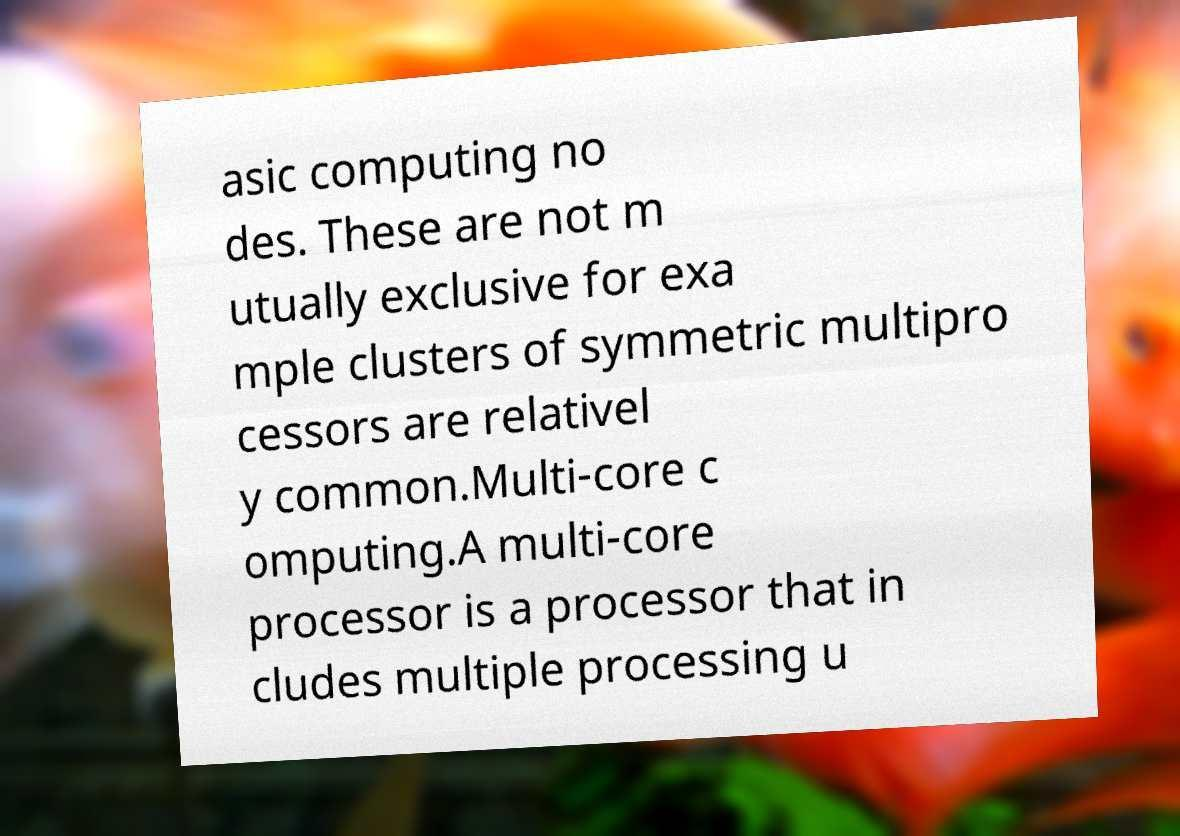Could you extract and type out the text from this image? asic computing no des. These are not m utually exclusive for exa mple clusters of symmetric multipro cessors are relativel y common.Multi-core c omputing.A multi-core processor is a processor that in cludes multiple processing u 